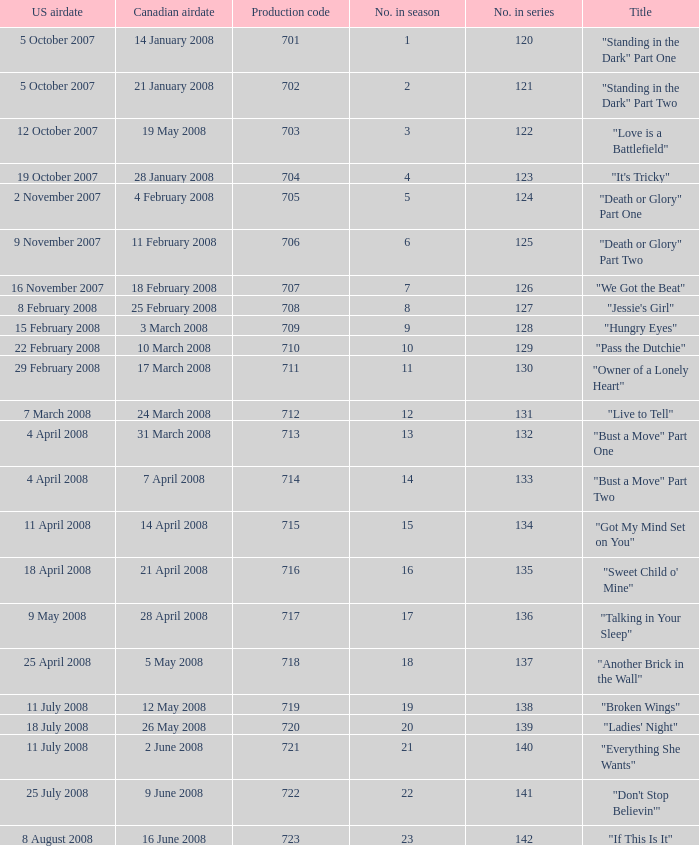For the episode(s) aired in the U.S. on 4 april 2008, what were the names? "Bust a Move" Part One, "Bust a Move" Part Two. 